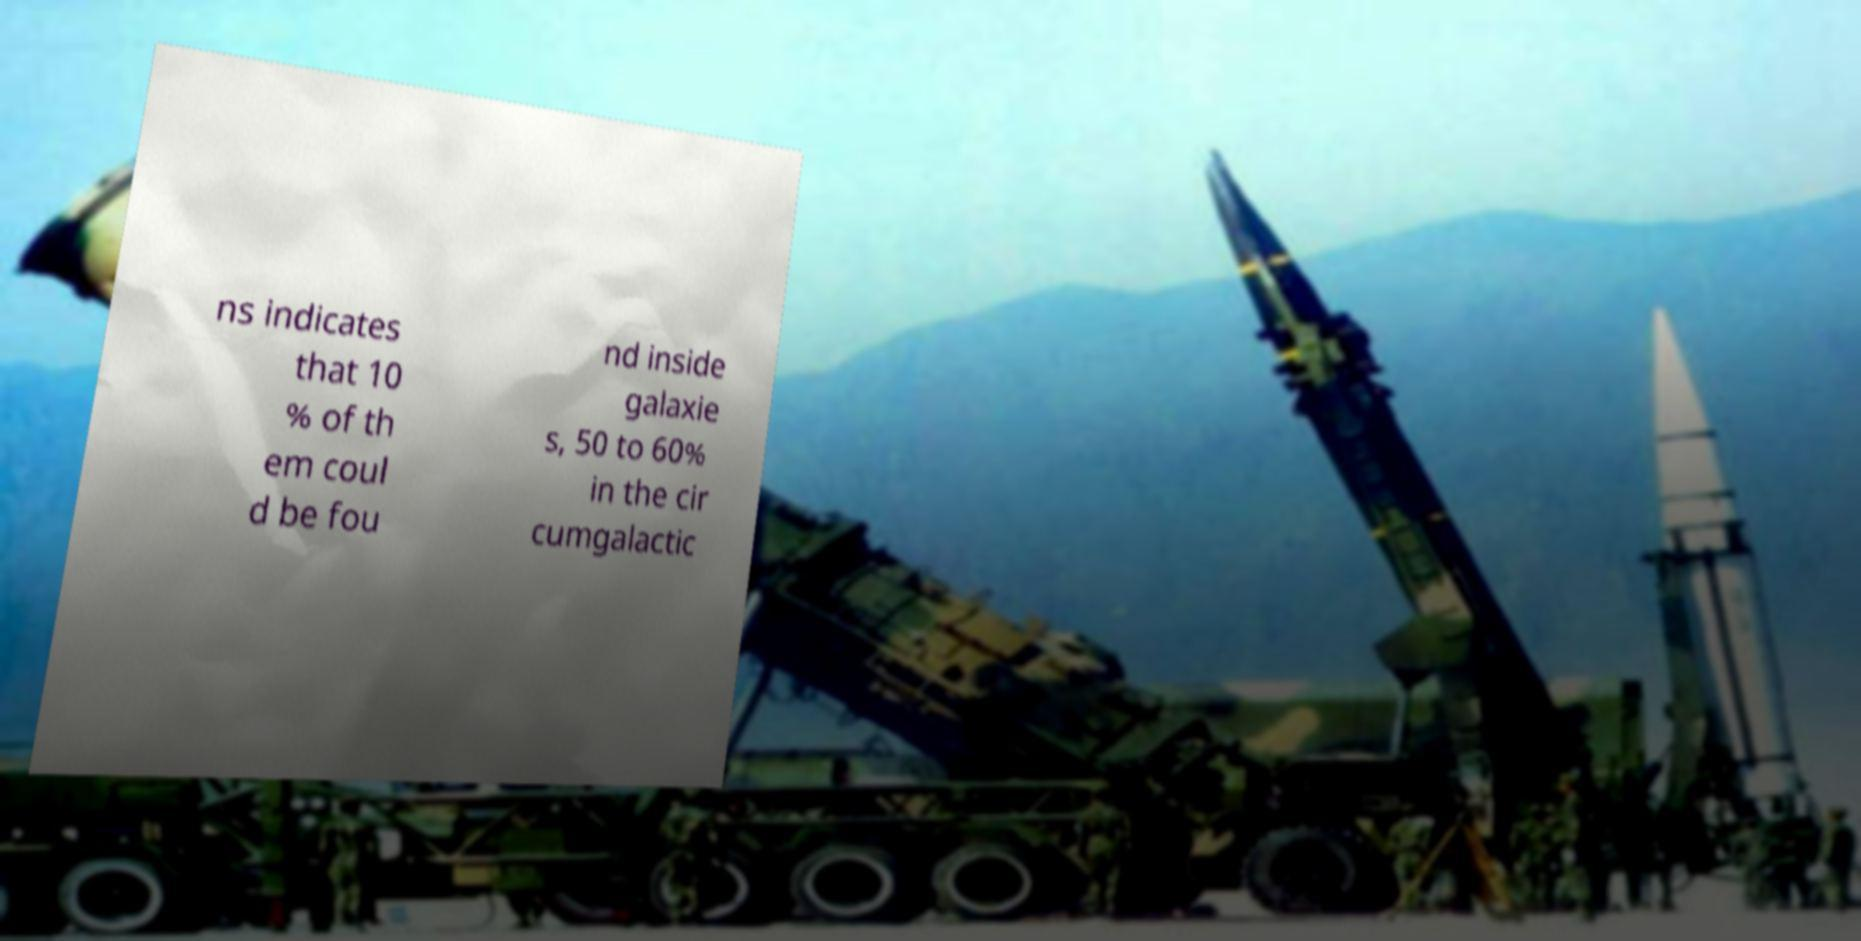Can you accurately transcribe the text from the provided image for me? ns indicates that 10 % of th em coul d be fou nd inside galaxie s, 50 to 60% in the cir cumgalactic 